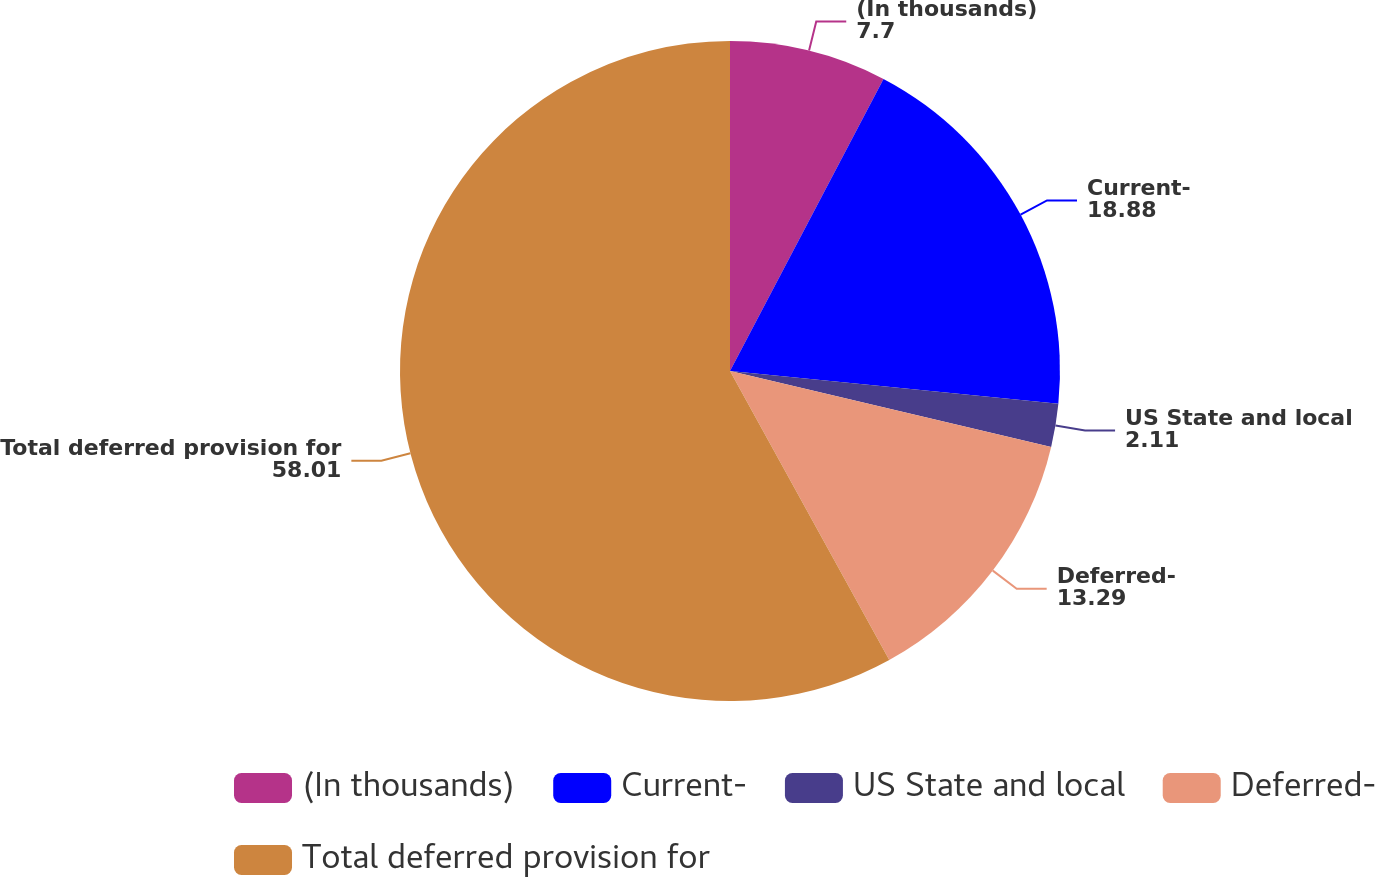Convert chart. <chart><loc_0><loc_0><loc_500><loc_500><pie_chart><fcel>(In thousands)<fcel>Current-<fcel>US State and local<fcel>Deferred-<fcel>Total deferred provision for<nl><fcel>7.7%<fcel>18.88%<fcel>2.11%<fcel>13.29%<fcel>58.01%<nl></chart> 